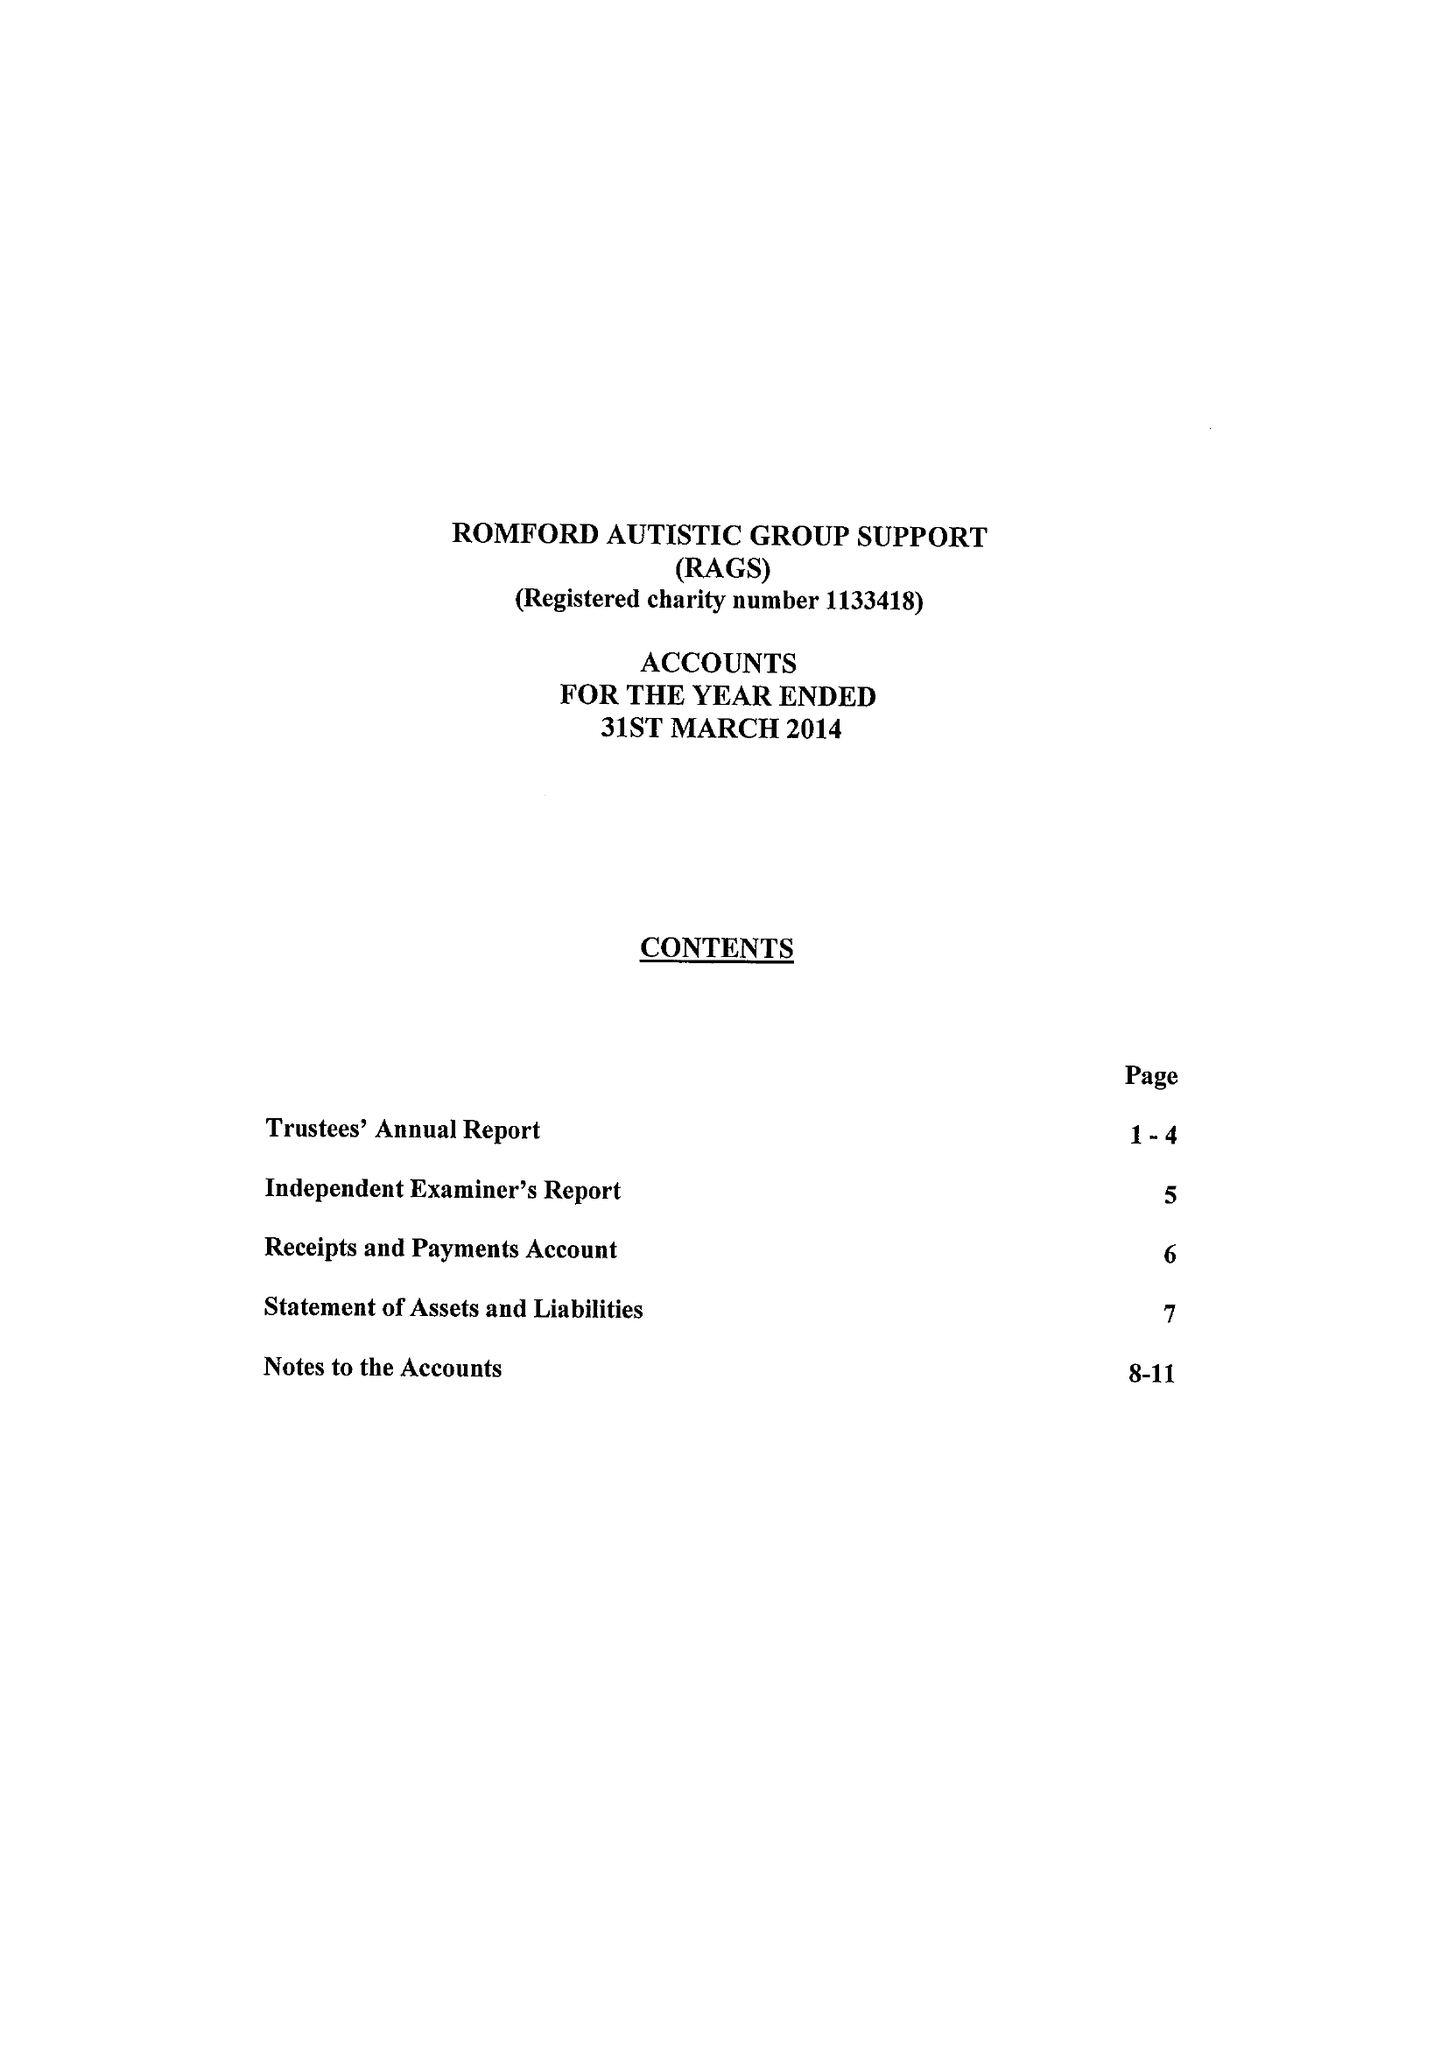What is the value for the charity_number?
Answer the question using a single word or phrase. 1133418 